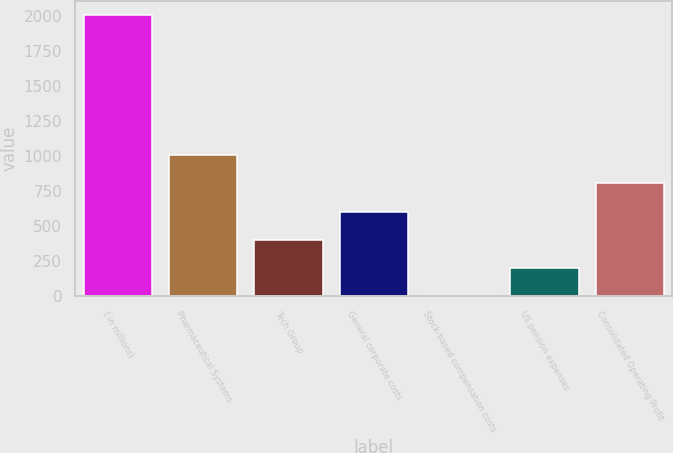Convert chart to OTSL. <chart><loc_0><loc_0><loc_500><loc_500><bar_chart><fcel>( in millions)<fcel>Pharmaceutical Systems<fcel>Tech Group<fcel>General corporate costs<fcel>Stock-based compensation costs<fcel>US pension expenses<fcel>Consolidated Operating Profit<nl><fcel>2007<fcel>1006.05<fcel>405.48<fcel>605.67<fcel>5.1<fcel>205.29<fcel>805.86<nl></chart> 